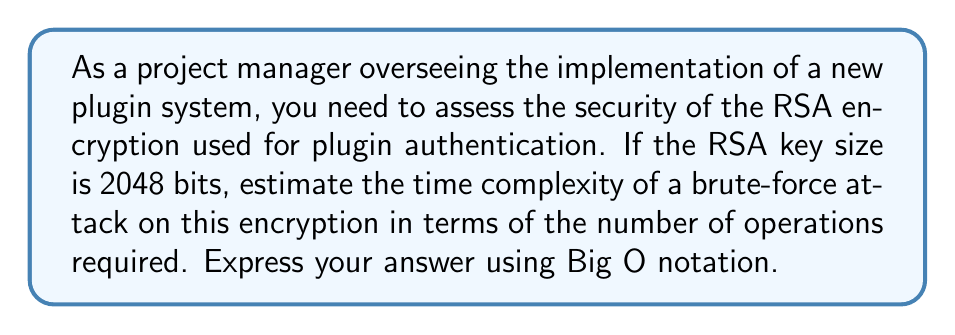Teach me how to tackle this problem. To estimate the time complexity of a brute-force attack on RSA encryption, we need to consider the following steps:

1. The security of RSA is based on the difficulty of factoring large numbers. For a 2048-bit key, we need to factor a number that is 2048 bits long.

2. The fastest known classical algorithm for factoring large numbers is the General Number Field Sieve (GNFS). The time complexity of GNFS is approximately:

   $$O(e^{((64/9)^{1/3} \cdot (\ln n)^{1/3} \cdot (\ln \ln n)^{2/3})})$$

   Where $n$ is the number to be factored.

3. For a 2048-bit RSA key, $n$ is approximately $2^{2048}$.

4. Substituting this into the GNFS time complexity formula:

   $$O(e^{((64/9)^{1/3} \cdot (\ln 2^{2048})^{1/3} \cdot (\ln \ln 2^{2048})^{2/3})})$$

5. Simplifying:
   $$O(e^{((64/9)^{1/3} \cdot (2048 \ln 2)^{1/3} \cdot (\ln(2048 \ln 2))^{2/3})})$$

6. This can be further approximated to:

   $$O(2^{(\frac{\sqrt[3]{64/9} \cdot \sqrt[3]{2048 \ln 2} \cdot (\ln(2048 \ln 2))^{2/3}}{\ln 2})})$$

7. Calculating this expression results in a complexity of approximately:

   $$O(2^{64})$$

Thus, the time complexity of a brute-force attack on a 2048-bit RSA encryption is approximately $O(2^{64})$ operations.
Answer: $O(2^{64})$ operations 